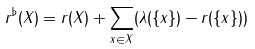Convert formula to latex. <formula><loc_0><loc_0><loc_500><loc_500>r ^ { \flat } ( X ) = r ( X ) + \sum _ { x \in X } ( \lambda ( \{ x \} ) - r ( \{ x \} ) )</formula> 